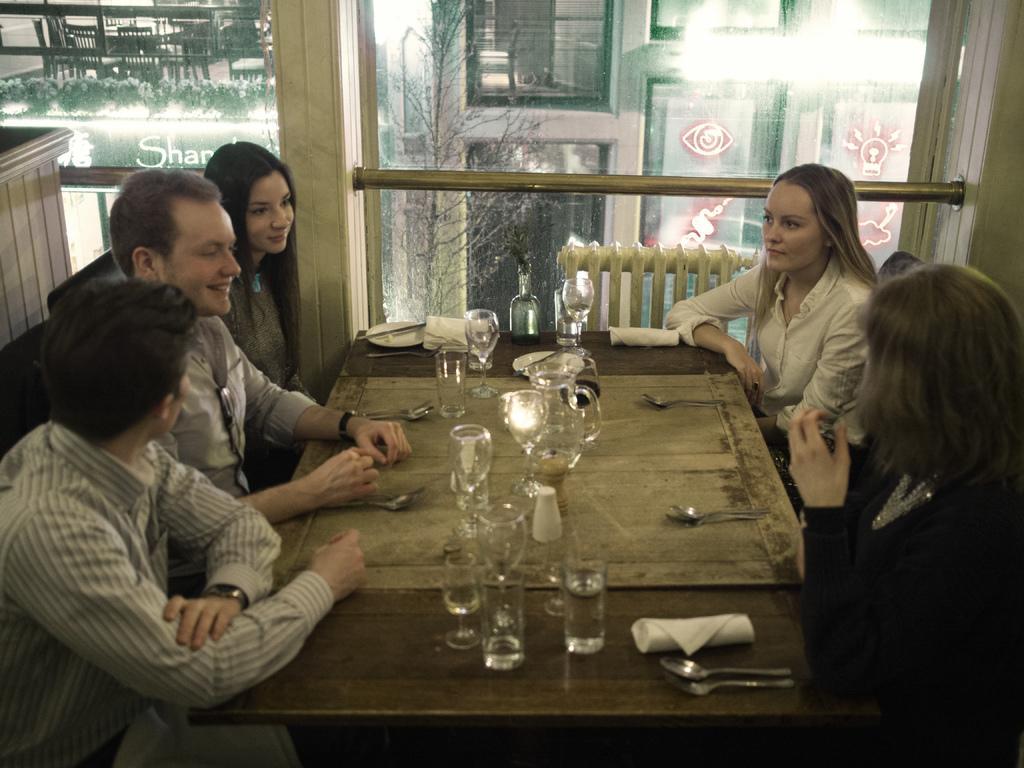Describe this image in one or two sentences. The picture is taken inside a room. In the middle there is a table. on the table there are glasses,spoon,napkin,bottle. There is chairs in the both side of the table. people are sitting on the chair. In the background there is glass wall. Through glass wall we can see another building and tree. The left corner person is wearing grey shirt. 